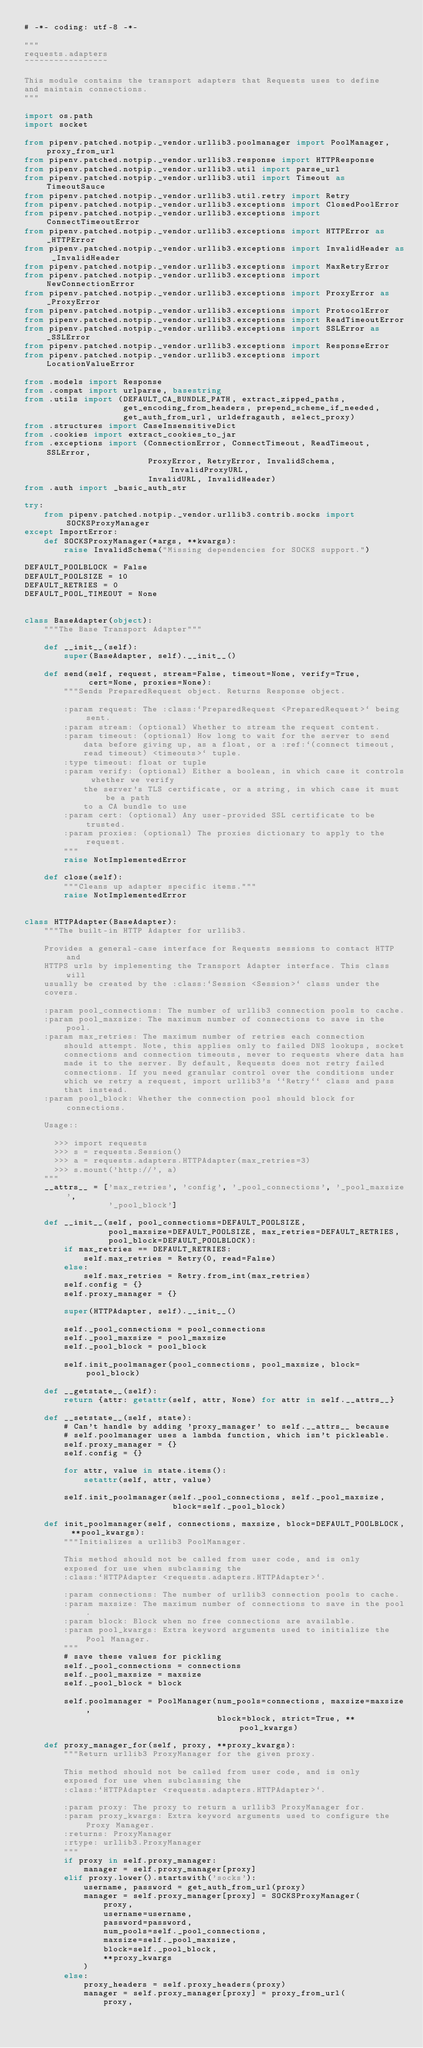<code> <loc_0><loc_0><loc_500><loc_500><_Python_># -*- coding: utf-8 -*-

"""
requests.adapters
~~~~~~~~~~~~~~~~~

This module contains the transport adapters that Requests uses to define
and maintain connections.
"""

import os.path
import socket

from pipenv.patched.notpip._vendor.urllib3.poolmanager import PoolManager, proxy_from_url
from pipenv.patched.notpip._vendor.urllib3.response import HTTPResponse
from pipenv.patched.notpip._vendor.urllib3.util import parse_url
from pipenv.patched.notpip._vendor.urllib3.util import Timeout as TimeoutSauce
from pipenv.patched.notpip._vendor.urllib3.util.retry import Retry
from pipenv.patched.notpip._vendor.urllib3.exceptions import ClosedPoolError
from pipenv.patched.notpip._vendor.urllib3.exceptions import ConnectTimeoutError
from pipenv.patched.notpip._vendor.urllib3.exceptions import HTTPError as _HTTPError
from pipenv.patched.notpip._vendor.urllib3.exceptions import InvalidHeader as _InvalidHeader
from pipenv.patched.notpip._vendor.urllib3.exceptions import MaxRetryError
from pipenv.patched.notpip._vendor.urllib3.exceptions import NewConnectionError
from pipenv.patched.notpip._vendor.urllib3.exceptions import ProxyError as _ProxyError
from pipenv.patched.notpip._vendor.urllib3.exceptions import ProtocolError
from pipenv.patched.notpip._vendor.urllib3.exceptions import ReadTimeoutError
from pipenv.patched.notpip._vendor.urllib3.exceptions import SSLError as _SSLError
from pipenv.patched.notpip._vendor.urllib3.exceptions import ResponseError
from pipenv.patched.notpip._vendor.urllib3.exceptions import LocationValueError

from .models import Response
from .compat import urlparse, basestring
from .utils import (DEFAULT_CA_BUNDLE_PATH, extract_zipped_paths,
                    get_encoding_from_headers, prepend_scheme_if_needed,
                    get_auth_from_url, urldefragauth, select_proxy)
from .structures import CaseInsensitiveDict
from .cookies import extract_cookies_to_jar
from .exceptions import (ConnectionError, ConnectTimeout, ReadTimeout, SSLError,
                         ProxyError, RetryError, InvalidSchema, InvalidProxyURL,
                         InvalidURL, InvalidHeader)
from .auth import _basic_auth_str

try:
    from pipenv.patched.notpip._vendor.urllib3.contrib.socks import SOCKSProxyManager
except ImportError:
    def SOCKSProxyManager(*args, **kwargs):
        raise InvalidSchema("Missing dependencies for SOCKS support.")

DEFAULT_POOLBLOCK = False
DEFAULT_POOLSIZE = 10
DEFAULT_RETRIES = 0
DEFAULT_POOL_TIMEOUT = None


class BaseAdapter(object):
    """The Base Transport Adapter"""

    def __init__(self):
        super(BaseAdapter, self).__init__()

    def send(self, request, stream=False, timeout=None, verify=True,
             cert=None, proxies=None):
        """Sends PreparedRequest object. Returns Response object.

        :param request: The :class:`PreparedRequest <PreparedRequest>` being sent.
        :param stream: (optional) Whether to stream the request content.
        :param timeout: (optional) How long to wait for the server to send
            data before giving up, as a float, or a :ref:`(connect timeout,
            read timeout) <timeouts>` tuple.
        :type timeout: float or tuple
        :param verify: (optional) Either a boolean, in which case it controls whether we verify
            the server's TLS certificate, or a string, in which case it must be a path
            to a CA bundle to use
        :param cert: (optional) Any user-provided SSL certificate to be trusted.
        :param proxies: (optional) The proxies dictionary to apply to the request.
        """
        raise NotImplementedError

    def close(self):
        """Cleans up adapter specific items."""
        raise NotImplementedError


class HTTPAdapter(BaseAdapter):
    """The built-in HTTP Adapter for urllib3.

    Provides a general-case interface for Requests sessions to contact HTTP and
    HTTPS urls by implementing the Transport Adapter interface. This class will
    usually be created by the :class:`Session <Session>` class under the
    covers.

    :param pool_connections: The number of urllib3 connection pools to cache.
    :param pool_maxsize: The maximum number of connections to save in the pool.
    :param max_retries: The maximum number of retries each connection
        should attempt. Note, this applies only to failed DNS lookups, socket
        connections and connection timeouts, never to requests where data has
        made it to the server. By default, Requests does not retry failed
        connections. If you need granular control over the conditions under
        which we retry a request, import urllib3's ``Retry`` class and pass
        that instead.
    :param pool_block: Whether the connection pool should block for connections.

    Usage::

      >>> import requests
      >>> s = requests.Session()
      >>> a = requests.adapters.HTTPAdapter(max_retries=3)
      >>> s.mount('http://', a)
    """
    __attrs__ = ['max_retries', 'config', '_pool_connections', '_pool_maxsize',
                 '_pool_block']

    def __init__(self, pool_connections=DEFAULT_POOLSIZE,
                 pool_maxsize=DEFAULT_POOLSIZE, max_retries=DEFAULT_RETRIES,
                 pool_block=DEFAULT_POOLBLOCK):
        if max_retries == DEFAULT_RETRIES:
            self.max_retries = Retry(0, read=False)
        else:
            self.max_retries = Retry.from_int(max_retries)
        self.config = {}
        self.proxy_manager = {}

        super(HTTPAdapter, self).__init__()

        self._pool_connections = pool_connections
        self._pool_maxsize = pool_maxsize
        self._pool_block = pool_block

        self.init_poolmanager(pool_connections, pool_maxsize, block=pool_block)

    def __getstate__(self):
        return {attr: getattr(self, attr, None) for attr in self.__attrs__}

    def __setstate__(self, state):
        # Can't handle by adding 'proxy_manager' to self.__attrs__ because
        # self.poolmanager uses a lambda function, which isn't pickleable.
        self.proxy_manager = {}
        self.config = {}

        for attr, value in state.items():
            setattr(self, attr, value)

        self.init_poolmanager(self._pool_connections, self._pool_maxsize,
                              block=self._pool_block)

    def init_poolmanager(self, connections, maxsize, block=DEFAULT_POOLBLOCK, **pool_kwargs):
        """Initializes a urllib3 PoolManager.

        This method should not be called from user code, and is only
        exposed for use when subclassing the
        :class:`HTTPAdapter <requests.adapters.HTTPAdapter>`.

        :param connections: The number of urllib3 connection pools to cache.
        :param maxsize: The maximum number of connections to save in the pool.
        :param block: Block when no free connections are available.
        :param pool_kwargs: Extra keyword arguments used to initialize the Pool Manager.
        """
        # save these values for pickling
        self._pool_connections = connections
        self._pool_maxsize = maxsize
        self._pool_block = block

        self.poolmanager = PoolManager(num_pools=connections, maxsize=maxsize,
                                       block=block, strict=True, **pool_kwargs)

    def proxy_manager_for(self, proxy, **proxy_kwargs):
        """Return urllib3 ProxyManager for the given proxy.

        This method should not be called from user code, and is only
        exposed for use when subclassing the
        :class:`HTTPAdapter <requests.adapters.HTTPAdapter>`.

        :param proxy: The proxy to return a urllib3 ProxyManager for.
        :param proxy_kwargs: Extra keyword arguments used to configure the Proxy Manager.
        :returns: ProxyManager
        :rtype: urllib3.ProxyManager
        """
        if proxy in self.proxy_manager:
            manager = self.proxy_manager[proxy]
        elif proxy.lower().startswith('socks'):
            username, password = get_auth_from_url(proxy)
            manager = self.proxy_manager[proxy] = SOCKSProxyManager(
                proxy,
                username=username,
                password=password,
                num_pools=self._pool_connections,
                maxsize=self._pool_maxsize,
                block=self._pool_block,
                **proxy_kwargs
            )
        else:
            proxy_headers = self.proxy_headers(proxy)
            manager = self.proxy_manager[proxy] = proxy_from_url(
                proxy,</code> 